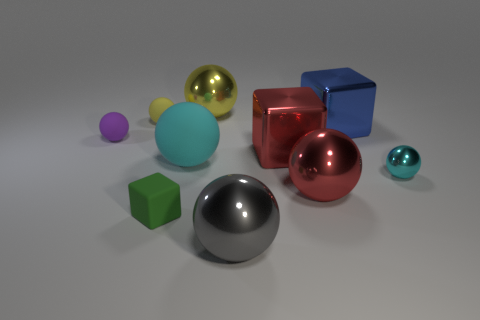Subtract all purple balls. How many balls are left? 6 Subtract all small purple spheres. How many spheres are left? 6 Subtract all gray blocks. Subtract all green cylinders. How many blocks are left? 3 Subtract all balls. How many objects are left? 3 Add 1 tiny blocks. How many tiny blocks exist? 2 Subtract 0 red cylinders. How many objects are left? 10 Subtract all tiny red cubes. Subtract all large red balls. How many objects are left? 9 Add 8 gray metal objects. How many gray metal objects are left? 9 